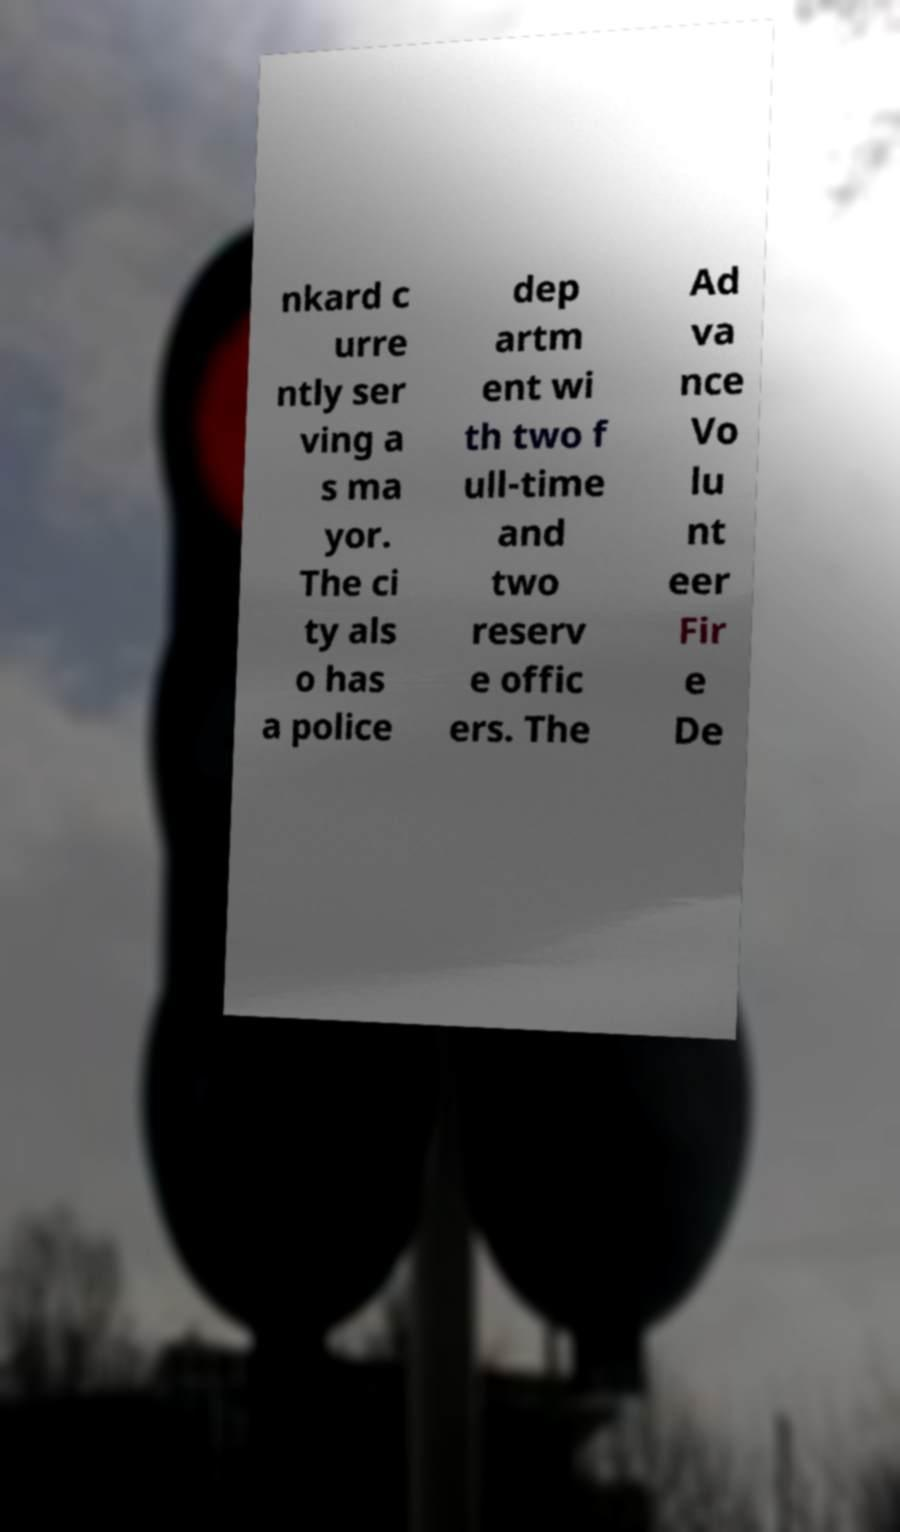I need the written content from this picture converted into text. Can you do that? nkard c urre ntly ser ving a s ma yor. The ci ty als o has a police dep artm ent wi th two f ull-time and two reserv e offic ers. The Ad va nce Vo lu nt eer Fir e De 